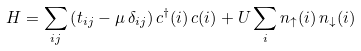Convert formula to latex. <formula><loc_0><loc_0><loc_500><loc_500>H = \sum _ { i j } \left ( t _ { i j } - \mu \, \delta _ { i j } \right ) c ^ { \dagger } ( i ) \, c ( i ) + U \sum _ { i } n _ { \uparrow } ( i ) \, n _ { \downarrow } ( i )</formula> 